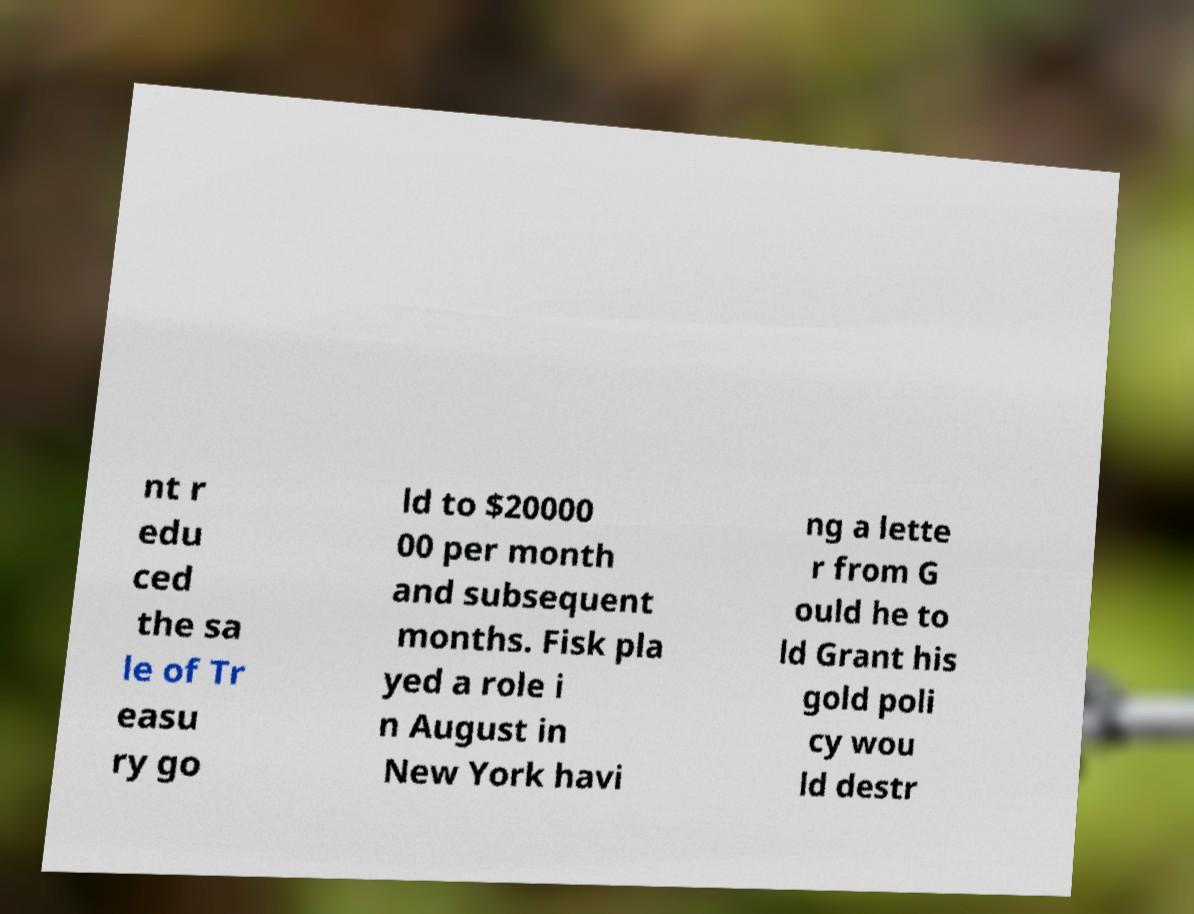Could you extract and type out the text from this image? nt r edu ced the sa le of Tr easu ry go ld to $20000 00 per month and subsequent months. Fisk pla yed a role i n August in New York havi ng a lette r from G ould he to ld Grant his gold poli cy wou ld destr 